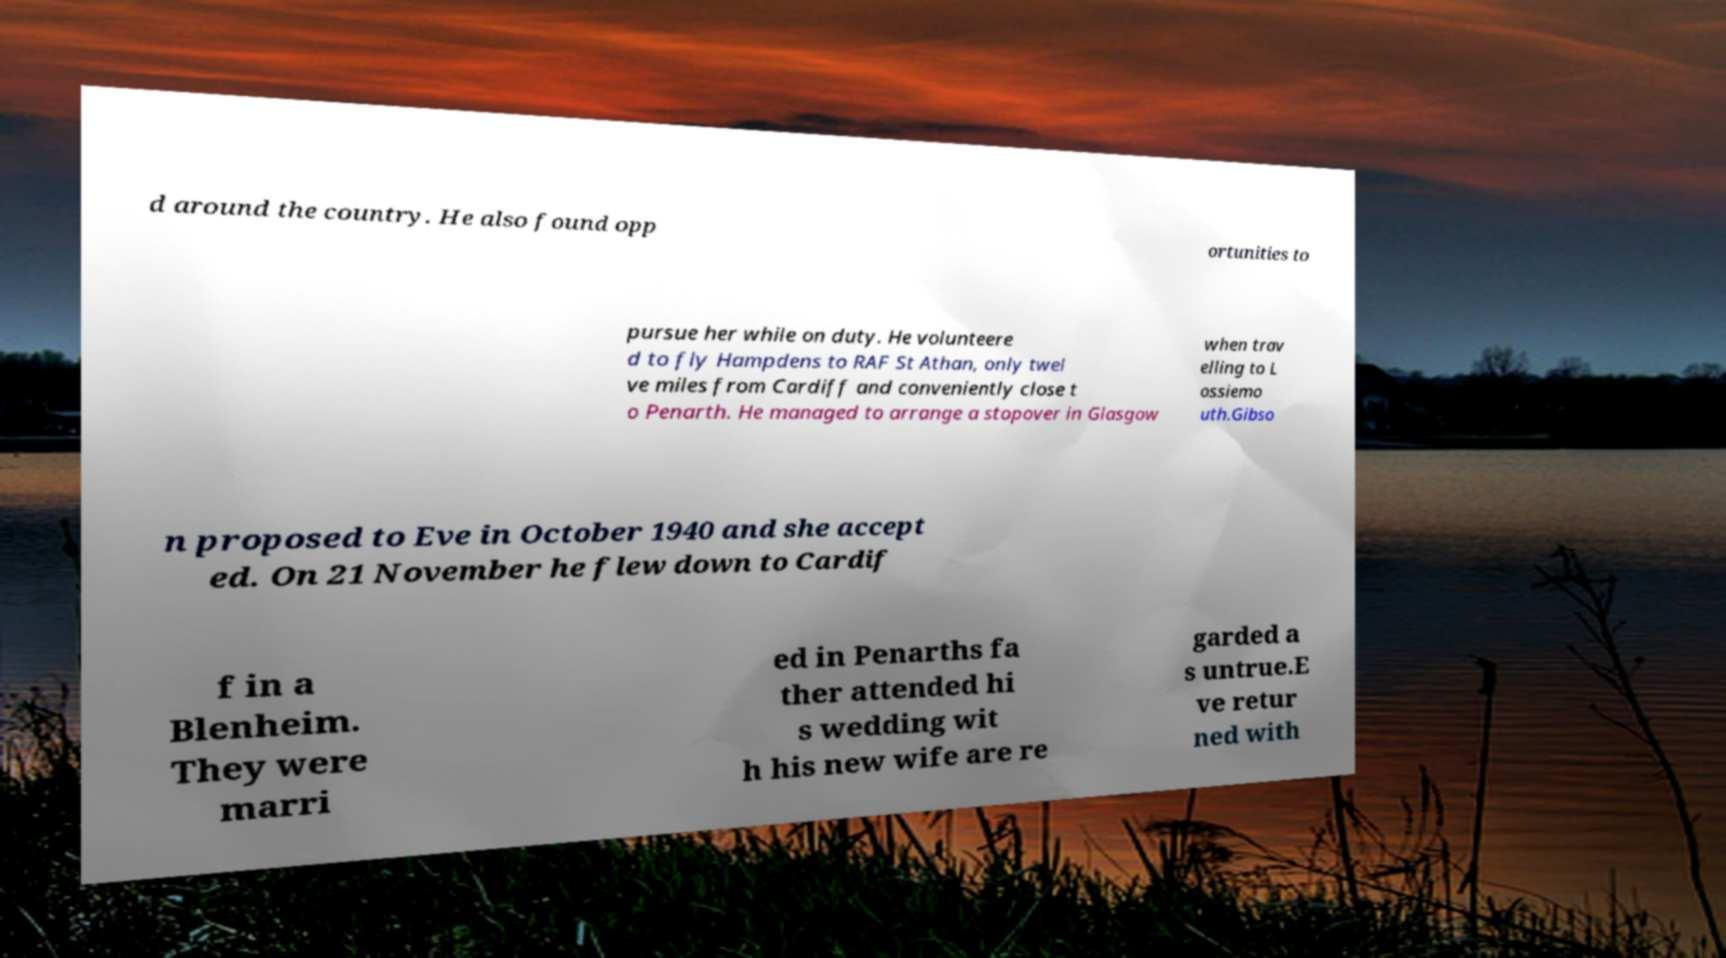Please read and relay the text visible in this image. What does it say? d around the country. He also found opp ortunities to pursue her while on duty. He volunteere d to fly Hampdens to RAF St Athan, only twel ve miles from Cardiff and conveniently close t o Penarth. He managed to arrange a stopover in Glasgow when trav elling to L ossiemo uth.Gibso n proposed to Eve in October 1940 and she accept ed. On 21 November he flew down to Cardif f in a Blenheim. They were marri ed in Penarths fa ther attended hi s wedding wit h his new wife are re garded a s untrue.E ve retur ned with 